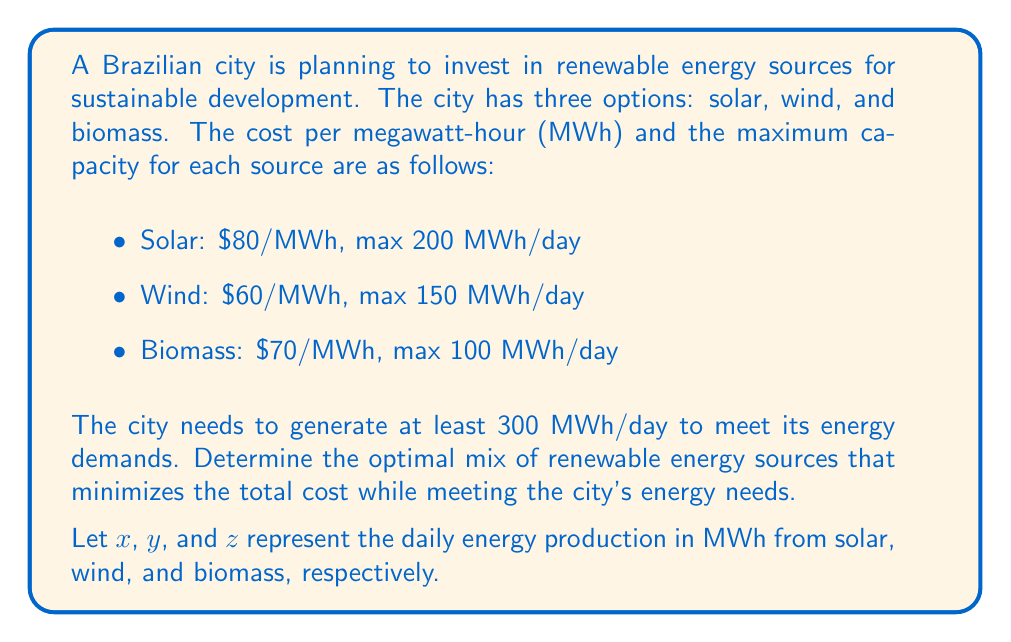Can you solve this math problem? To solve this optimization problem, we'll use linear programming:

1. Define the objective function:
   Minimize total cost: $$ C = 80x + 60y + 70z $$

2. Set up constraints:
   a) Meet energy demand: $$ x + y + z \geq 300 $$
   b) Capacity limits:
      $$ 0 \leq x \leq 200 $$
      $$ 0 \leq y \leq 150 $$
      $$ 0 \leq z \leq 100 $$

3. Solve using the simplex method or a linear programming solver.

4. The optimal solution is:
   $$ x = 0 \text{ MWh (Solar)} $$
   $$ y = 150 \text{ MWh (Wind)} $$
   $$ z = 150 \text{ MWh (Biomass)} $$

5. Calculate the minimum total cost:
   $$ C = 80(0) + 60(150) + 70(150) = 19,500 $$

This solution utilizes the full capacity of the cheaper wind energy and supplements it with biomass to meet the demand, avoiding the more expensive solar energy.
Answer: The optimal renewable energy mix is 0 MWh from solar, 150 MWh from wind, and 150 MWh from biomass, with a total daily cost of $19,500. 